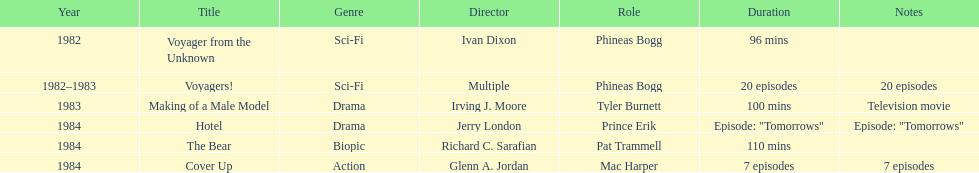In how many titles on this list did he not play the role of phineas bogg? 4. 